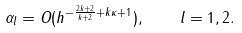<formula> <loc_0><loc_0><loc_500><loc_500>\alpha _ { l } = O ( h ^ { - \frac { 2 k + 2 } { k + 2 } + k \kappa + 1 } ) , \quad l = 1 , 2 .</formula> 